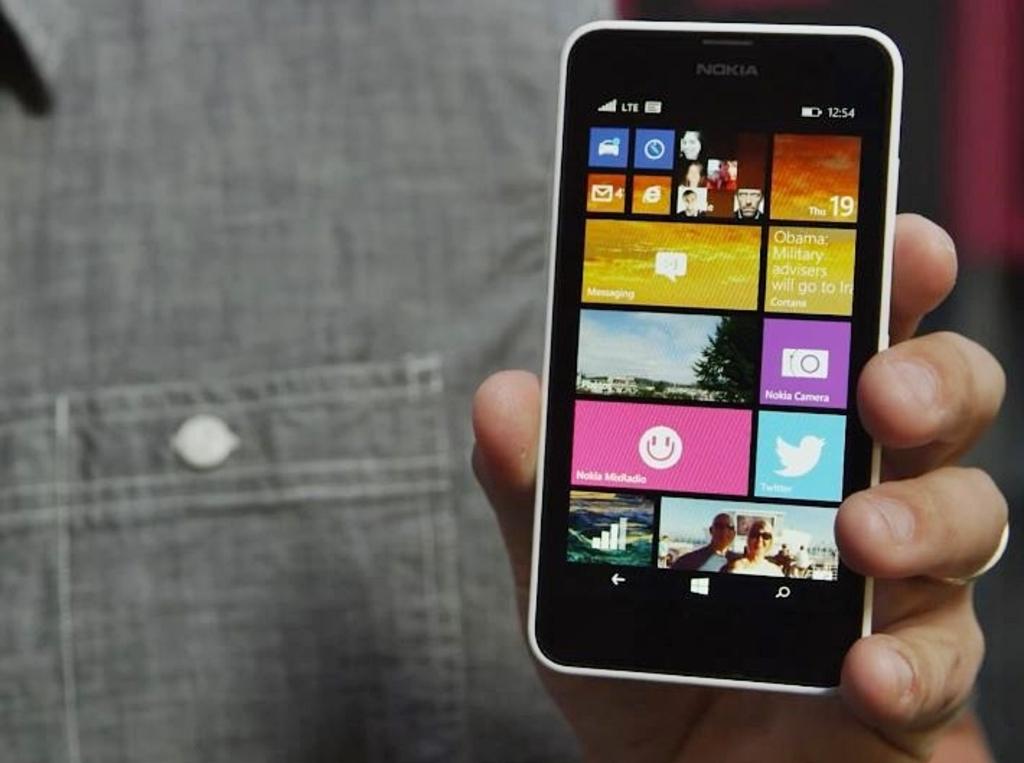What icon is the purple app?
Your answer should be compact. Nokia camera. 